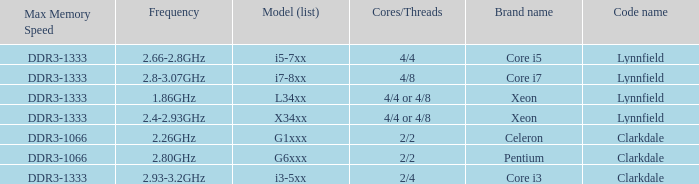What is the maximum memory speed for frequencies between 2.93-3.2ghz? DDR3-1333. Parse the full table. {'header': ['Max Memory Speed', 'Frequency', 'Model (list)', 'Cores/Threads', 'Brand name', 'Code name'], 'rows': [['DDR3-1333', '2.66-2.8GHz', 'i5-7xx', '4/4', 'Core i5', 'Lynnfield'], ['DDR3-1333', '2.8-3.07GHz', 'i7-8xx', '4/8', 'Core i7', 'Lynnfield'], ['DDR3-1333', '1.86GHz', 'L34xx', '4/4 or 4/8', 'Xeon', 'Lynnfield'], ['DDR3-1333', '2.4-2.93GHz', 'X34xx', '4/4 or 4/8', 'Xeon', 'Lynnfield'], ['DDR3-1066', '2.26GHz', 'G1xxx', '2/2', 'Celeron', 'Clarkdale'], ['DDR3-1066', '2.80GHz', 'G6xxx', '2/2', 'Pentium', 'Clarkdale'], ['DDR3-1333', '2.93-3.2GHz', 'i3-5xx', '2/4', 'Core i3', 'Clarkdale']]} 